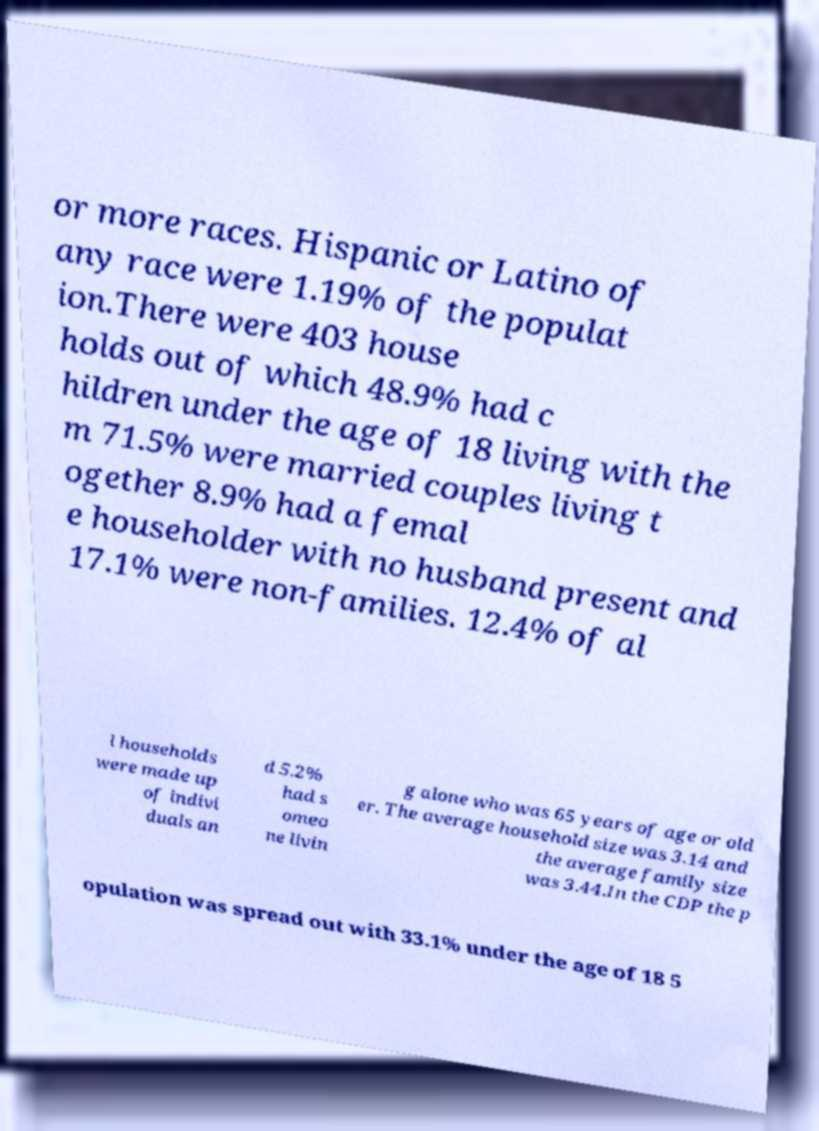Could you assist in decoding the text presented in this image and type it out clearly? or more races. Hispanic or Latino of any race were 1.19% of the populat ion.There were 403 house holds out of which 48.9% had c hildren under the age of 18 living with the m 71.5% were married couples living t ogether 8.9% had a femal e householder with no husband present and 17.1% were non-families. 12.4% of al l households were made up of indivi duals an d 5.2% had s omeo ne livin g alone who was 65 years of age or old er. The average household size was 3.14 and the average family size was 3.44.In the CDP the p opulation was spread out with 33.1% under the age of 18 5 